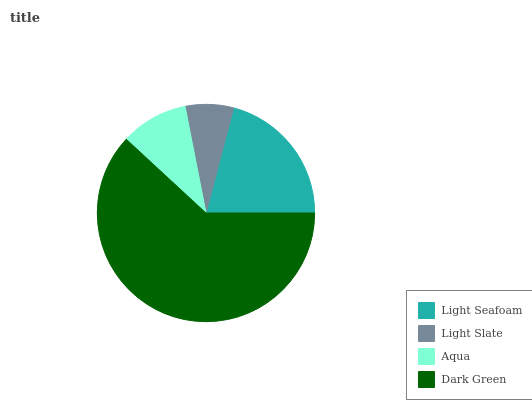Is Light Slate the minimum?
Answer yes or no. Yes. Is Dark Green the maximum?
Answer yes or no. Yes. Is Aqua the minimum?
Answer yes or no. No. Is Aqua the maximum?
Answer yes or no. No. Is Aqua greater than Light Slate?
Answer yes or no. Yes. Is Light Slate less than Aqua?
Answer yes or no. Yes. Is Light Slate greater than Aqua?
Answer yes or no. No. Is Aqua less than Light Slate?
Answer yes or no. No. Is Light Seafoam the high median?
Answer yes or no. Yes. Is Aqua the low median?
Answer yes or no. Yes. Is Aqua the high median?
Answer yes or no. No. Is Light Seafoam the low median?
Answer yes or no. No. 